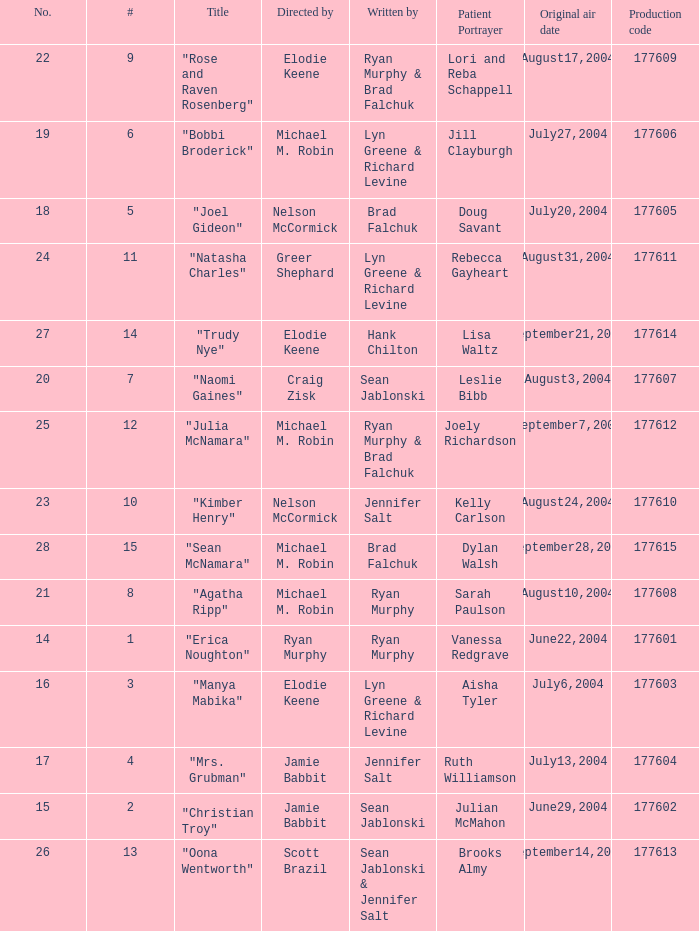Who wrote episode number 28? Brad Falchuk. 